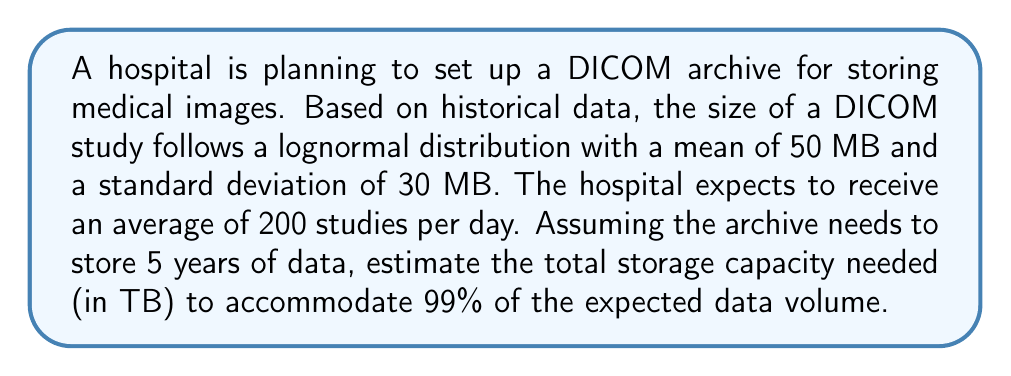Solve this math problem. To solve this problem, we'll follow these steps:

1. Calculate the parameters of the lognormal distribution
2. Find the 99th percentile of the study size distribution
3. Calculate the total number of studies over 5 years
4. Estimate the total storage capacity needed

Step 1: Calculate the lognormal distribution parameters

For a lognormal distribution with mean $\mu$ and standard deviation $\sigma$, we need to find $\mu_{\ln}$ and $\sigma_{\ln}$:

$$\mu_{\ln} = \ln\left(\frac{\mu^2}{\sqrt{\mu^2 + \sigma^2}}\right)$$
$$\sigma_{\ln} = \sqrt{\ln\left(1 + \frac{\sigma^2}{\mu^2}\right)}$$

Substituting $\mu = 50$ and $\sigma = 30$:

$$\mu_{\ln} = \ln\left(\frac{50^2}{\sqrt{50^2 + 30^2}}\right) = 3.7651$$
$$\sigma_{\ln} = \sqrt{\ln\left(1 + \frac{30^2}{50^2}\right)} = 0.5493$$

Step 2: Find the 99th percentile of the study size distribution

The 99th percentile of a lognormal distribution is given by:

$$x_{99} = e^{\mu_{\ln} + \sigma_{\ln} \cdot z_{0.99}}$$

Where $z_{0.99} = 2.3263$ (standard normal distribution 99th percentile)

$$x_{99} = e^{3.7651 + 0.5493 \cdot 2.3263} = 131.8489 \text{ MB}$$

Step 3: Calculate the total number of studies over 5 years

Number of studies per year = 200 studies/day * 365 days = 73,000 studies/year
Total studies in 5 years = 73,000 * 5 = 365,000 studies

Step 4: Estimate the total storage capacity needed

Total storage = Number of studies * 99th percentile study size
$$\text{Total storage} = 365,000 \cdot 131.8489 \text{ MB} = 48,124,848.5 \text{ MB}$$

Converting to TB:
$$\text{Storage in TB} = \frac{48,124,848.5 \text{ MB}}{1,048,576 \text{ MB/TB}} = 45.8913 \text{ TB}$$
Answer: The estimated storage capacity needed for the DICOM archive to accommodate 99% of the expected data volume over 5 years is approximately 45.89 TB. 